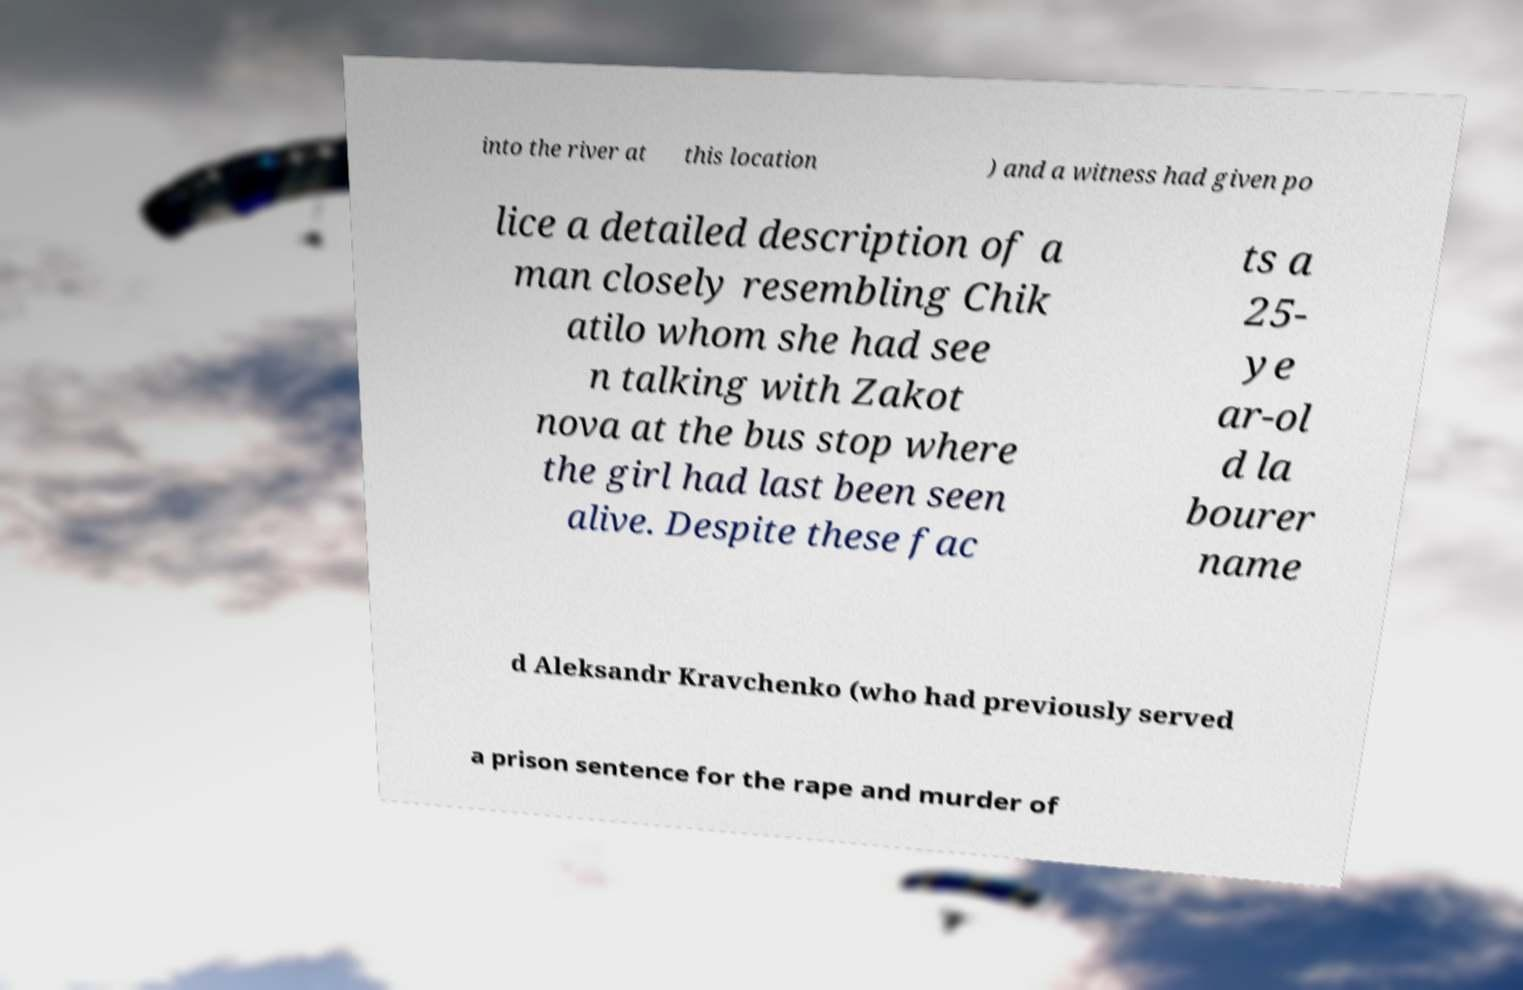Could you extract and type out the text from this image? into the river at this location ) and a witness had given po lice a detailed description of a man closely resembling Chik atilo whom she had see n talking with Zakot nova at the bus stop where the girl had last been seen alive. Despite these fac ts a 25- ye ar-ol d la bourer name d Aleksandr Kravchenko (who had previously served a prison sentence for the rape and murder of 